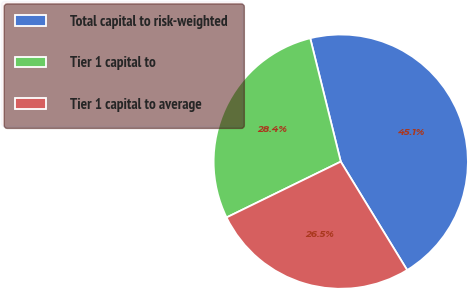<chart> <loc_0><loc_0><loc_500><loc_500><pie_chart><fcel>Total capital to risk-weighted<fcel>Tier 1 capital to<fcel>Tier 1 capital to average<nl><fcel>45.11%<fcel>28.37%<fcel>26.51%<nl></chart> 